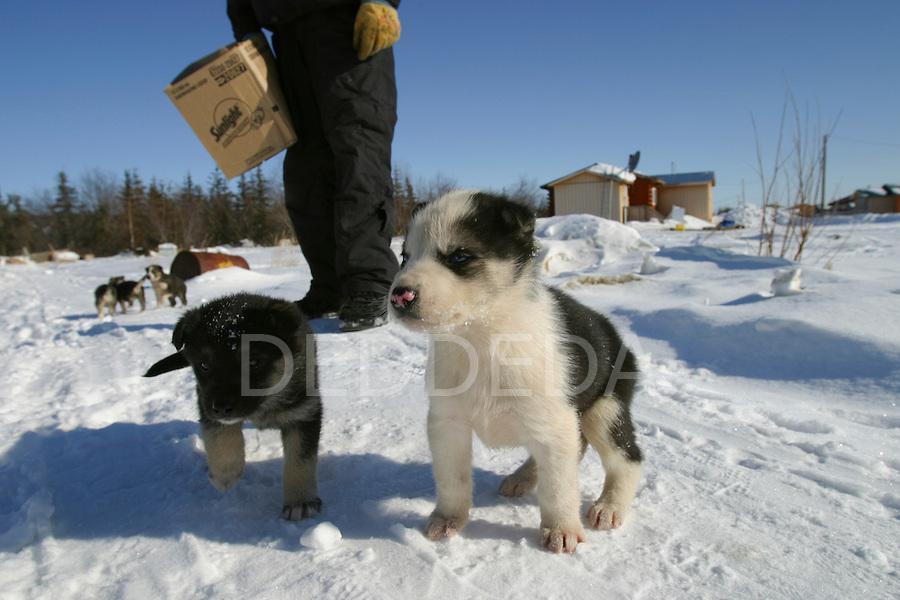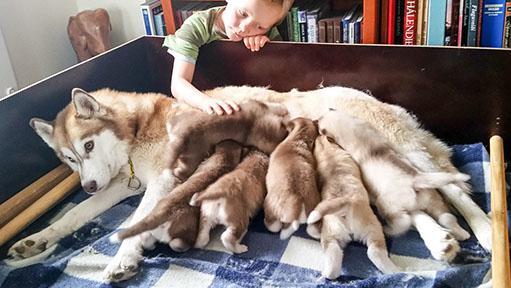The first image is the image on the left, the second image is the image on the right. Analyze the images presented: Is the assertion "Each image shows at least one dog in a sled, and one image features at least three young puppies in a sled with something red behind them." valid? Answer yes or no. No. The first image is the image on the left, the second image is the image on the right. Examine the images to the left and right. Is the description "Two dogs sit on a wooden structure in the image on the left." accurate? Answer yes or no. No. 